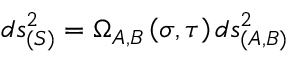Convert formula to latex. <formula><loc_0><loc_0><loc_500><loc_500>d s _ { ( S ) } ^ { 2 } = \Omega _ { A , B } \left ( \sigma , \tau \right ) d s _ { ( A , B ) } ^ { 2 }</formula> 